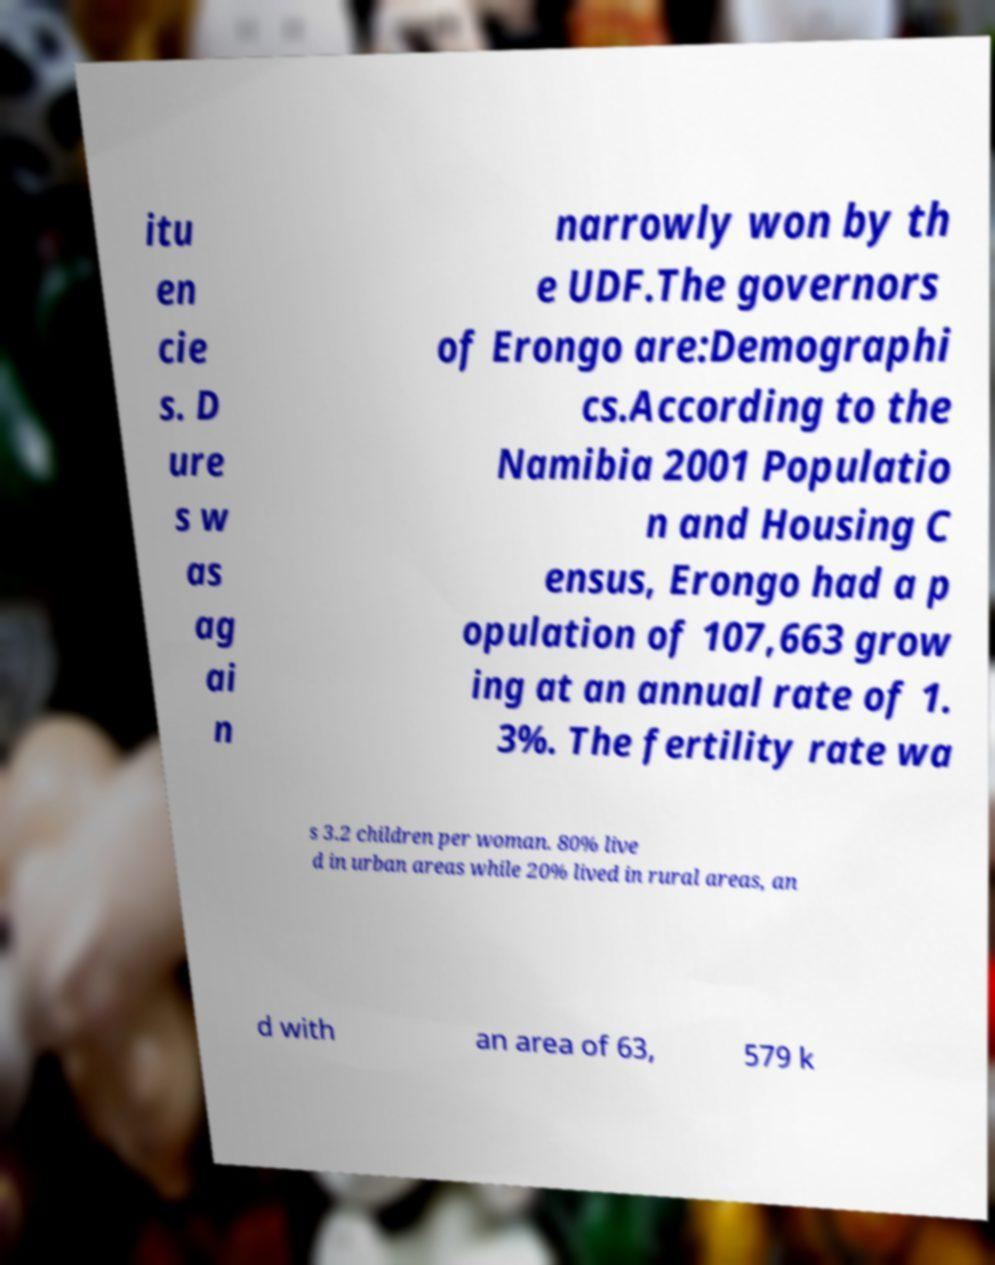Please identify and transcribe the text found in this image. itu en cie s. D ure s w as ag ai n narrowly won by th e UDF.The governors of Erongo are:Demographi cs.According to the Namibia 2001 Populatio n and Housing C ensus, Erongo had a p opulation of 107,663 grow ing at an annual rate of 1. 3%. The fertility rate wa s 3.2 children per woman. 80% live d in urban areas while 20% lived in rural areas, an d with an area of 63, 579 k 